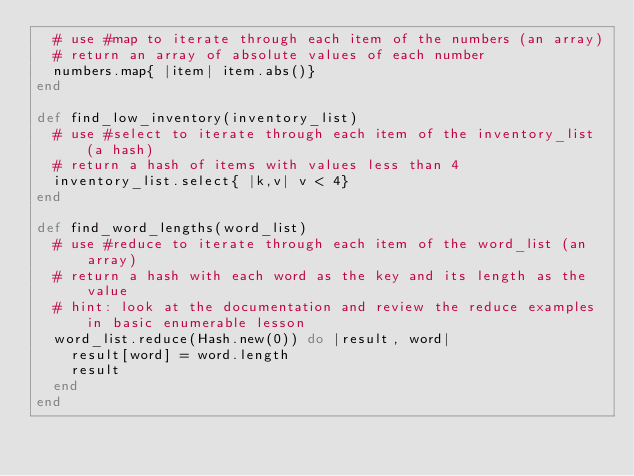<code> <loc_0><loc_0><loc_500><loc_500><_Ruby_>  # use #map to iterate through each item of the numbers (an array)
  # return an array of absolute values of each number
  numbers.map{ |item| item.abs()}
end

def find_low_inventory(inventory_list)
  # use #select to iterate through each item of the inventory_list (a hash)
  # return a hash of items with values less than 4
  inventory_list.select{ |k,v| v < 4}
end

def find_word_lengths(word_list)
  # use #reduce to iterate through each item of the word_list (an array)
  # return a hash with each word as the key and its length as the value
  # hint: look at the documentation and review the reduce examples in basic enumerable lesson
  word_list.reduce(Hash.new(0)) do |result, word|  
    result[word] = word.length
    result
  end
end
</code> 